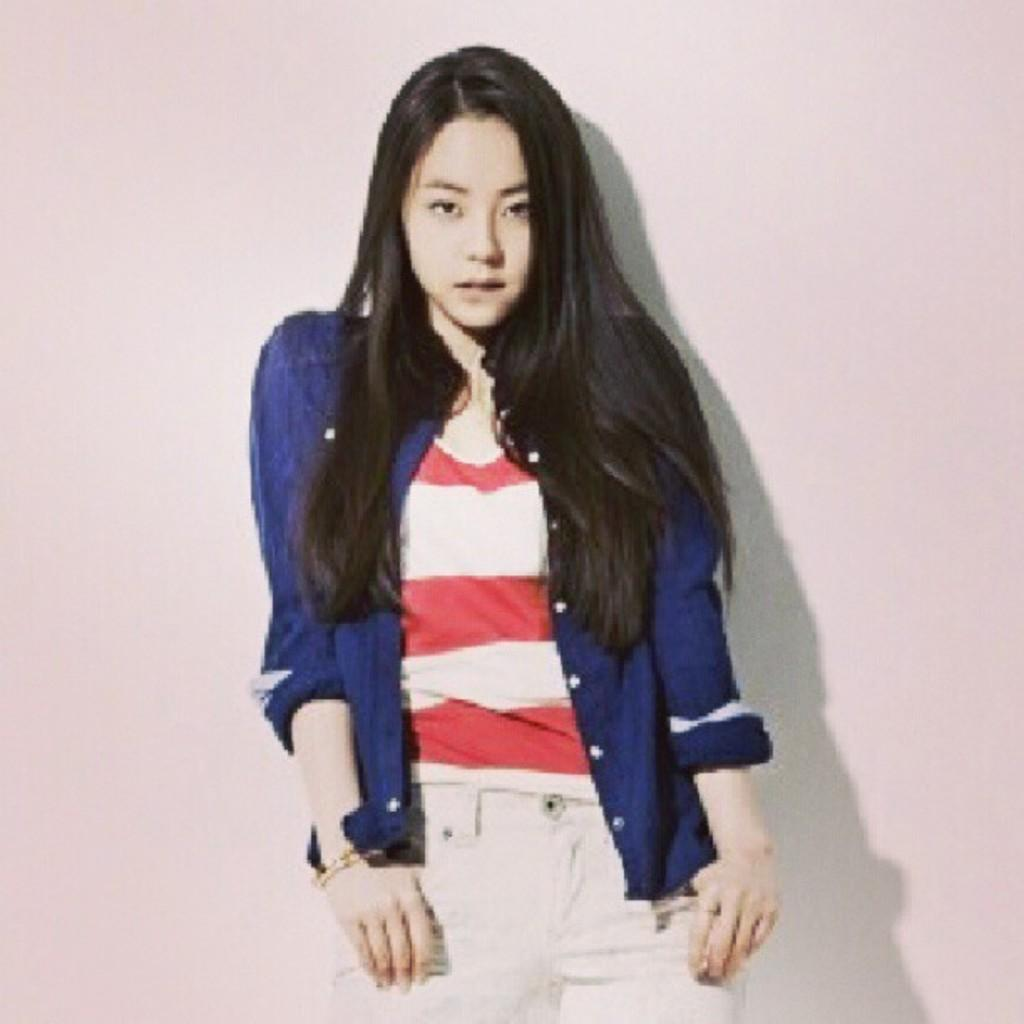Who is the main subject in the image? There is a woman in the image. What is the woman wearing? The woman is wearing a blue shirt. What color is the background of the image? The background of the image is white. Where is the lake located in the image? There is no lake present in the image. What type of servant is assisting the woman in the image? There is no servant present in the image. 